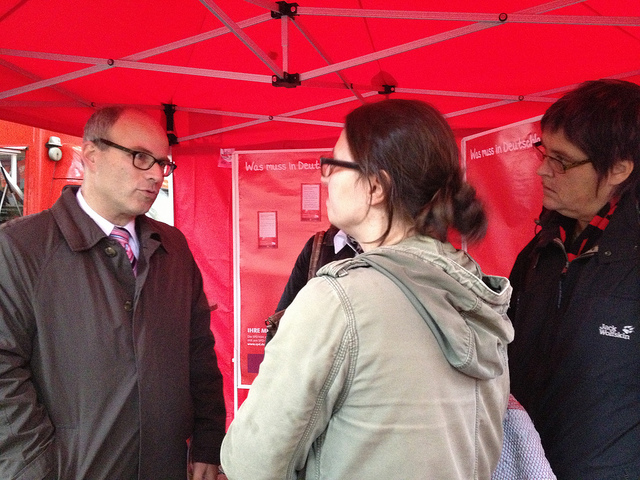Read all the text in this image. Was Wacsidn 